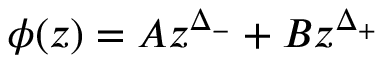Convert formula to latex. <formula><loc_0><loc_0><loc_500><loc_500>\phi ( z ) = A z ^ { \Delta _ { - } } + B z ^ { \Delta _ { + } }</formula> 